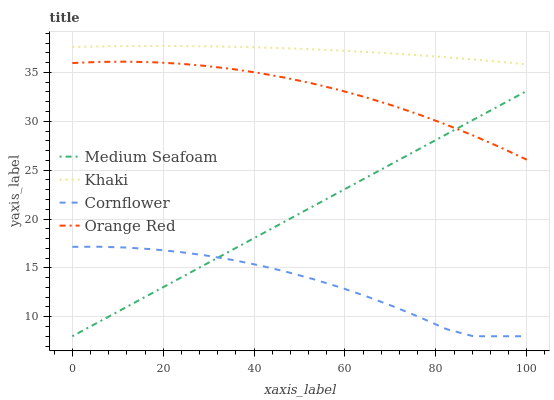Does Cornflower have the minimum area under the curve?
Answer yes or no. Yes. Does Khaki have the maximum area under the curve?
Answer yes or no. Yes. Does Medium Seafoam have the minimum area under the curve?
Answer yes or no. No. Does Medium Seafoam have the maximum area under the curve?
Answer yes or no. No. Is Medium Seafoam the smoothest?
Answer yes or no. Yes. Is Cornflower the roughest?
Answer yes or no. Yes. Is Khaki the smoothest?
Answer yes or no. No. Is Khaki the roughest?
Answer yes or no. No. Does Khaki have the lowest value?
Answer yes or no. No. Does Khaki have the highest value?
Answer yes or no. Yes. Does Medium Seafoam have the highest value?
Answer yes or no. No. Is Orange Red less than Khaki?
Answer yes or no. Yes. Is Orange Red greater than Cornflower?
Answer yes or no. Yes. Does Medium Seafoam intersect Orange Red?
Answer yes or no. Yes. Is Medium Seafoam less than Orange Red?
Answer yes or no. No. Is Medium Seafoam greater than Orange Red?
Answer yes or no. No. Does Orange Red intersect Khaki?
Answer yes or no. No. 